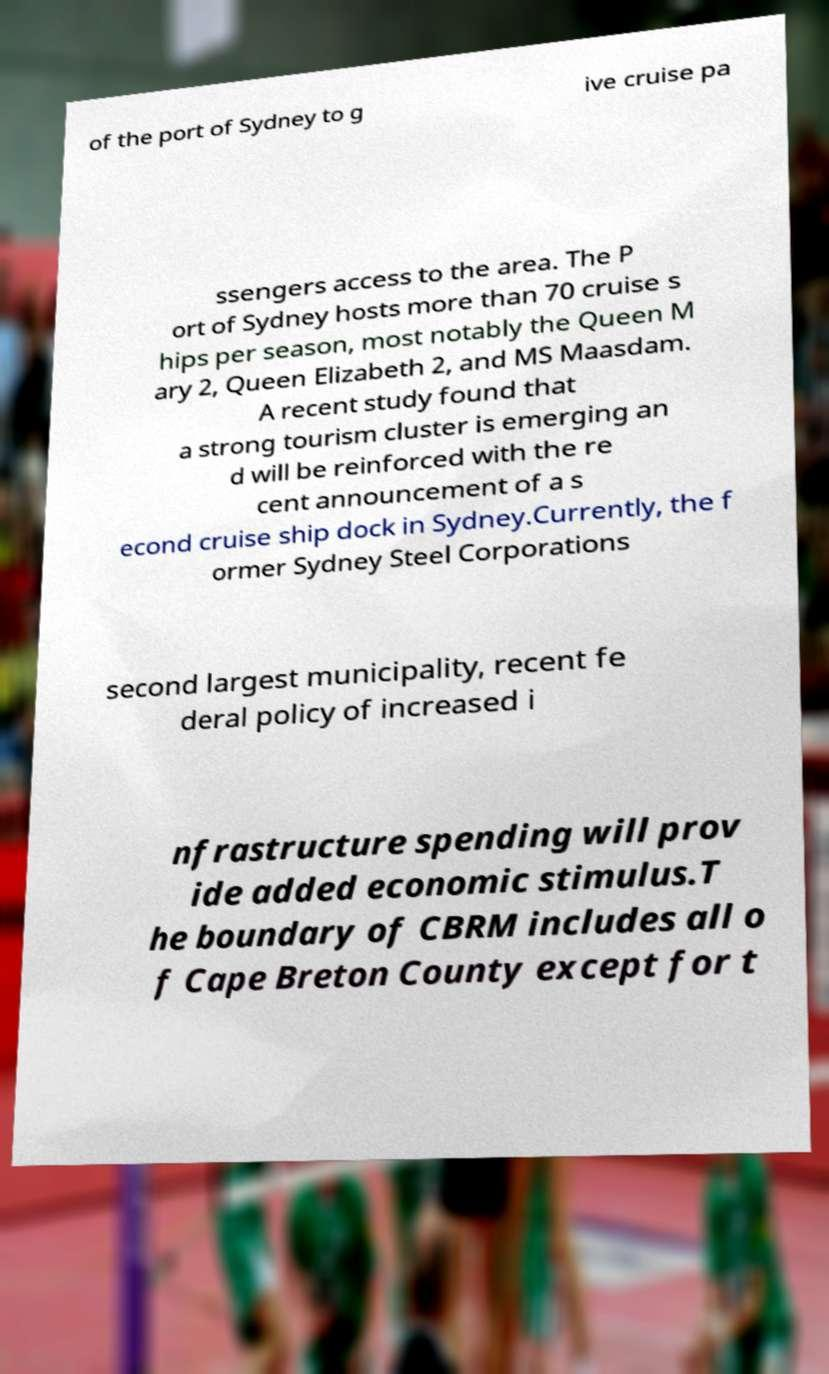For documentation purposes, I need the text within this image transcribed. Could you provide that? of the port of Sydney to g ive cruise pa ssengers access to the area. The P ort of Sydney hosts more than 70 cruise s hips per season, most notably the Queen M ary 2, Queen Elizabeth 2, and MS Maasdam. A recent study found that a strong tourism cluster is emerging an d will be reinforced with the re cent announcement of a s econd cruise ship dock in Sydney.Currently, the f ormer Sydney Steel Corporations second largest municipality, recent fe deral policy of increased i nfrastructure spending will prov ide added economic stimulus.T he boundary of CBRM includes all o f Cape Breton County except for t 